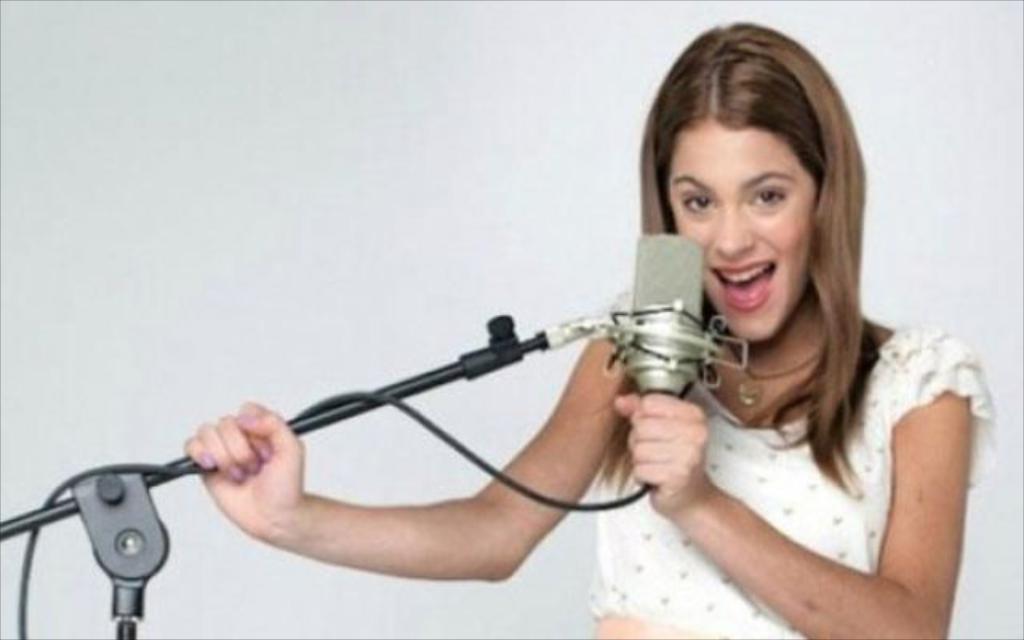Can you describe this image briefly? On the right side of this image I can see a woman is holding a mike stand in hands. It seems like she is singing a song. 